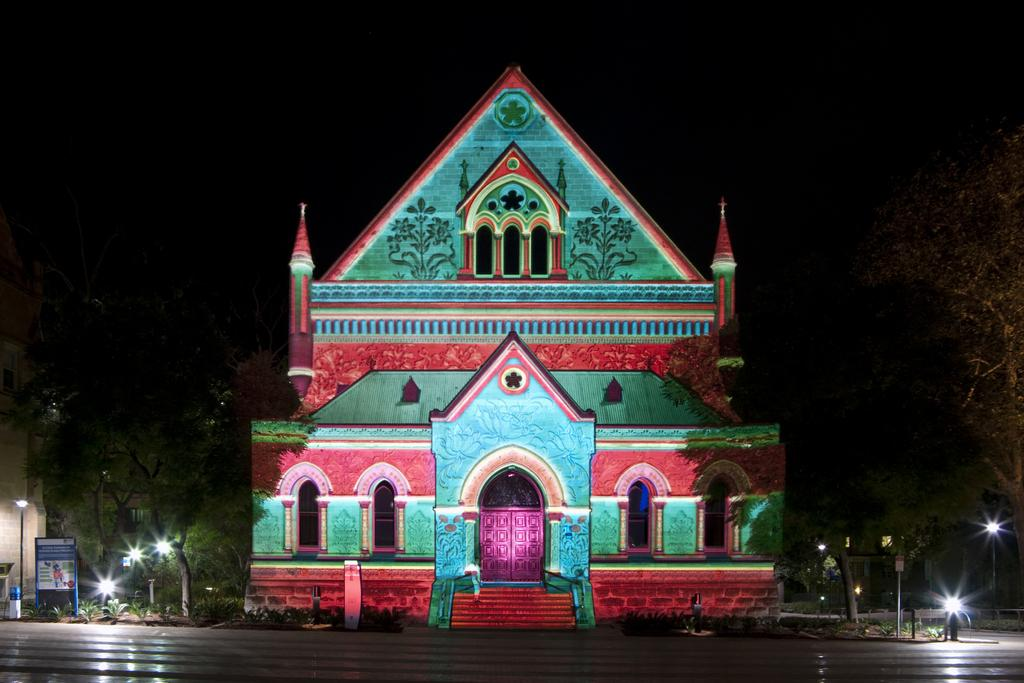What type of structure is visible in the image? There is a building in the image. What features can be seen on the building? The building has windows, doors, arches, and steps. What is present on the sides of the building? There are trees and lights on the sides of the building. What is located on the left side of the building? There is a board on the left side of the building. How would you describe the overall appearance of the image? The background of the image is dark. What type of language is being spoken by the people in the image? There are no people visible in the image, so it is not possible to determine what language might be spoken. What type of breakfast is being served in the image? There is no food or reference to breakfast in the image. 